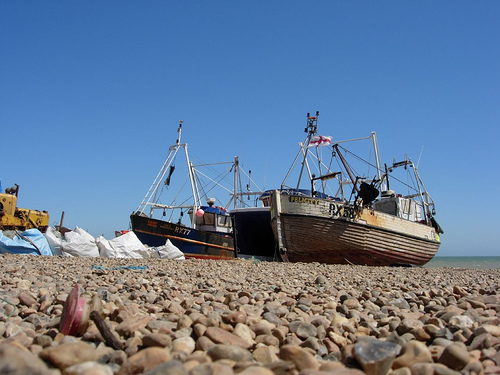Please transcribe the text information in this image. PX58 